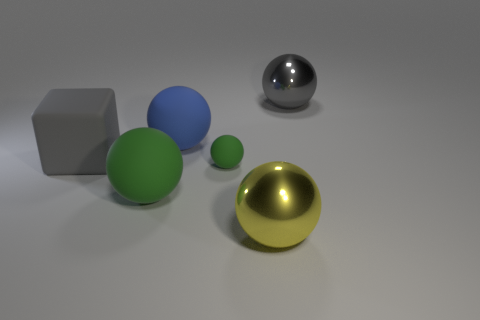Does the large yellow thing have the same material as the green thing that is right of the big green object?
Provide a succinct answer. No. What number of objects are either large objects in front of the gray block or yellow cubes?
Offer a very short reply. 2. There is a metal thing that is in front of the large gray thing that is right of the gray thing that is on the left side of the big blue matte sphere; how big is it?
Provide a short and direct response. Large. What is the material of the large ball that is the same color as the small ball?
Your answer should be very brief. Rubber. Are there any other things that are the same shape as the tiny matte object?
Ensure brevity in your answer.  Yes. There is a metal thing on the left side of the shiny sphere that is behind the big gray rubber object; what is its size?
Provide a short and direct response. Large. How many small things are either yellow metallic spheres or blue balls?
Your answer should be very brief. 0. Is the number of rubber blocks less than the number of big yellow cylinders?
Make the answer very short. No. Does the rubber block have the same color as the tiny thing?
Keep it short and to the point. No. Are there more big cyan blocks than large gray metallic spheres?
Your response must be concise. No. 